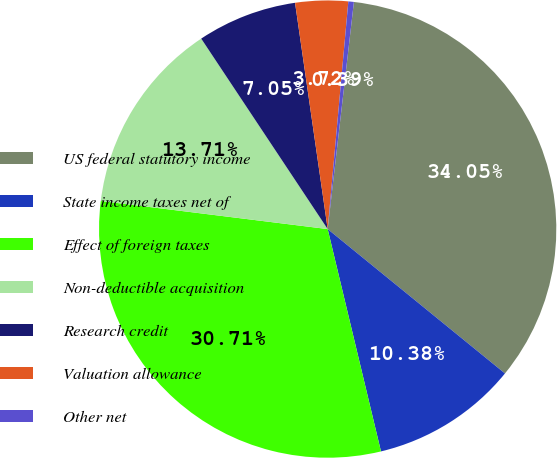<chart> <loc_0><loc_0><loc_500><loc_500><pie_chart><fcel>US federal statutory income<fcel>State income taxes net of<fcel>Effect of foreign taxes<fcel>Non-deductible acquisition<fcel>Research credit<fcel>Valuation allowance<fcel>Other net<nl><fcel>34.05%<fcel>10.38%<fcel>30.71%<fcel>13.71%<fcel>7.05%<fcel>3.72%<fcel>0.39%<nl></chart> 